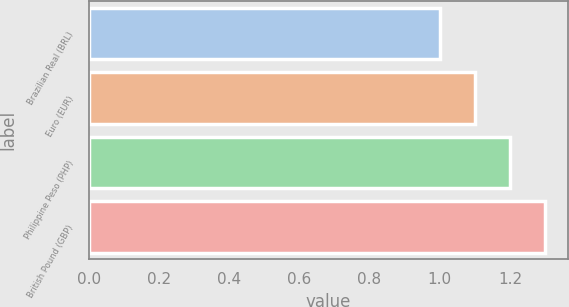Convert chart. <chart><loc_0><loc_0><loc_500><loc_500><bar_chart><fcel>Brazilian Real (BRL)<fcel>Euro (EUR)<fcel>Philippine Peso (PHP)<fcel>British Pound (GBP)<nl><fcel>1<fcel>1.1<fcel>1.2<fcel>1.3<nl></chart> 